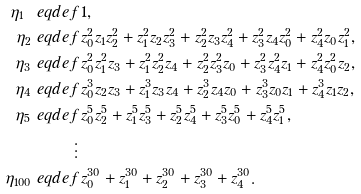<formula> <loc_0><loc_0><loc_500><loc_500>\eta _ { 1 } \ e q d e f & \, 1 , \\ \eta _ { 2 } \ e q d e f & \, z _ { 0 } ^ { 2 } z _ { 1 } z _ { 2 } ^ { 2 } + z _ { 1 } ^ { 2 } z _ { 2 } z _ { 3 } ^ { 2 } + z _ { 2 } ^ { 2 } z _ { 3 } z _ { 4 } ^ { 2 } + z _ { 3 } ^ { 2 } z _ { 4 } z _ { 0 } ^ { 2 } + z _ { 4 } ^ { 2 } z _ { 0 } z _ { 1 } ^ { 2 } , \\ \eta _ { 3 } \ e q d e f & \, z _ { 0 } ^ { 2 } z _ { 1 } ^ { 2 } z _ { 3 } + z _ { 1 } ^ { 2 } z _ { 2 } ^ { 2 } z _ { 4 } + z _ { 2 } ^ { 2 } z _ { 3 } ^ { 2 } z _ { 0 } + z _ { 3 } ^ { 2 } z _ { 4 } ^ { 2 } z _ { 1 } + z _ { 4 } ^ { 2 } z _ { 0 } ^ { 2 } z _ { 2 } , \\ \eta _ { 4 } \ e q d e f & \, z _ { 0 } ^ { 3 } z _ { 2 } z _ { 3 } + z _ { 1 } ^ { 3 } z _ { 3 } z _ { 4 } + z _ { 2 } ^ { 3 } z _ { 4 } z _ { 0 } + z _ { 3 } ^ { 3 } z _ { 0 } z _ { 1 } + z _ { 4 } ^ { 3 } z _ { 1 } z _ { 2 } , \\ \eta _ { 5 } \ e q d e f & \, z _ { 0 } ^ { 5 } z _ { 2 } ^ { 5 } + z _ { 1 } ^ { 5 } z _ { 3 } ^ { 5 } + z _ { 2 } ^ { 5 } z _ { 4 } ^ { 5 } + z _ { 3 } ^ { 5 } z _ { 0 } ^ { 5 } + z _ { 4 } ^ { 5 } z _ { 1 } ^ { 5 } , \\ \vdots & \\ \eta _ { 1 0 0 } \ e q d e f & \, z _ { 0 } ^ { 3 0 } + z _ { 1 } ^ { 3 0 } + z _ { 2 } ^ { 3 0 } + z _ { 3 } ^ { 3 0 } + z _ { 4 } ^ { 3 0 } .</formula> 